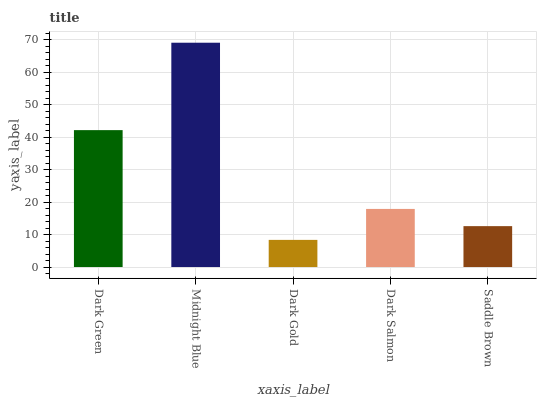Is Dark Gold the minimum?
Answer yes or no. Yes. Is Midnight Blue the maximum?
Answer yes or no. Yes. Is Midnight Blue the minimum?
Answer yes or no. No. Is Dark Gold the maximum?
Answer yes or no. No. Is Midnight Blue greater than Dark Gold?
Answer yes or no. Yes. Is Dark Gold less than Midnight Blue?
Answer yes or no. Yes. Is Dark Gold greater than Midnight Blue?
Answer yes or no. No. Is Midnight Blue less than Dark Gold?
Answer yes or no. No. Is Dark Salmon the high median?
Answer yes or no. Yes. Is Dark Salmon the low median?
Answer yes or no. Yes. Is Dark Gold the high median?
Answer yes or no. No. Is Dark Green the low median?
Answer yes or no. No. 